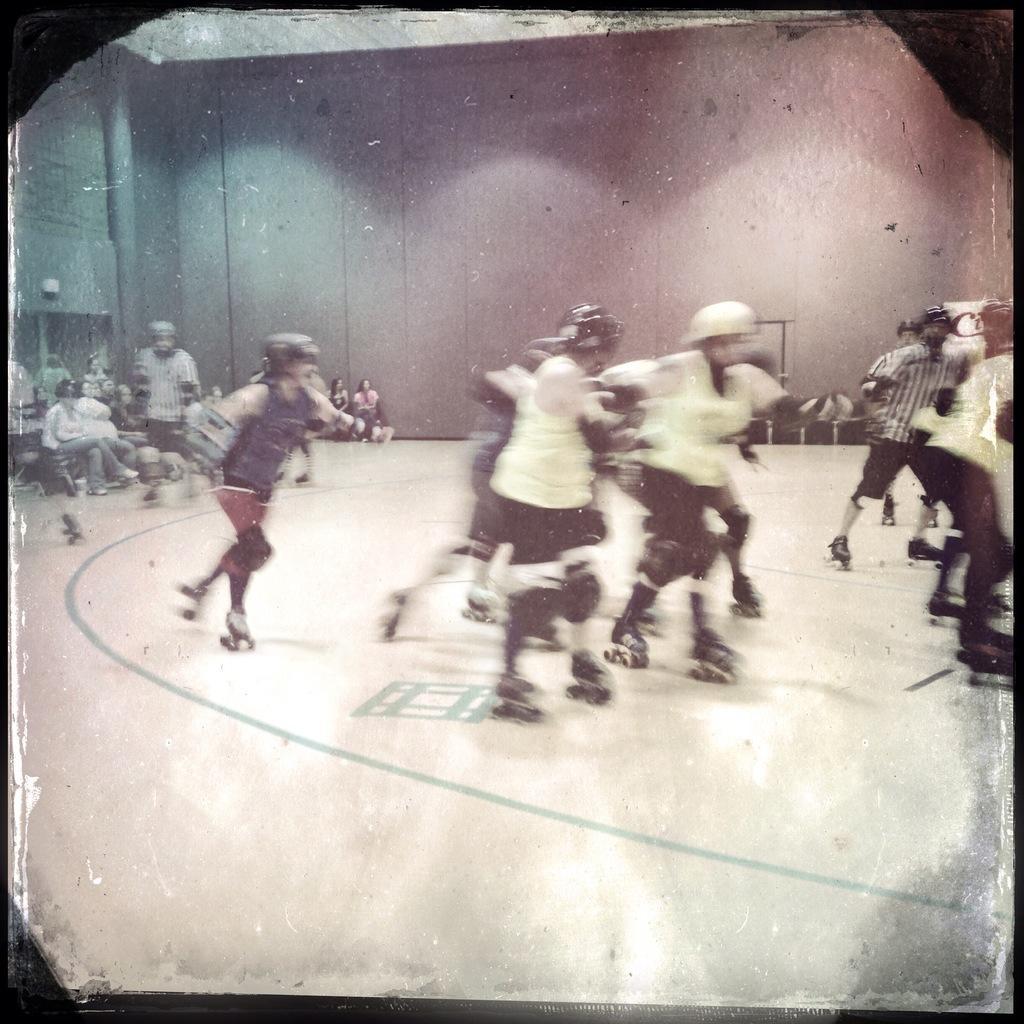Could you give a brief overview of what you see in this image? In this image we can see people wearing the helmet and skating with the skateboards on the surface. In the background we can see the wall. We can also see the people sitting on the chairs and the image has borders. 